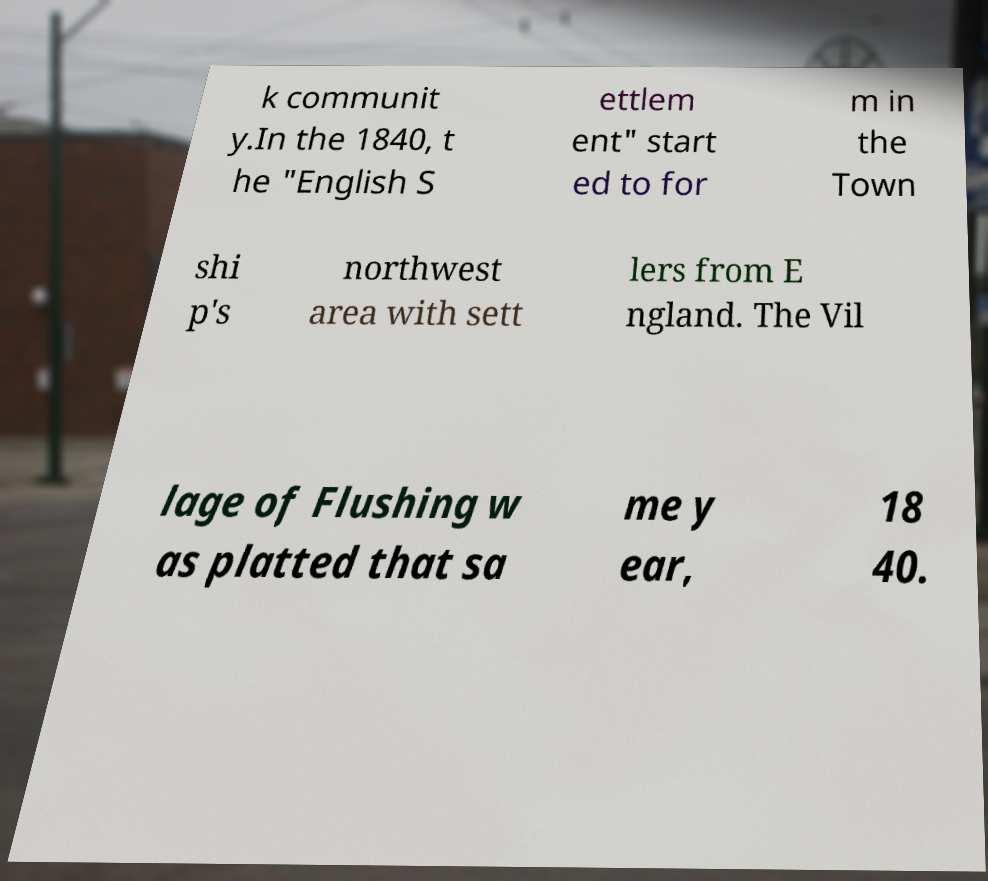Could you extract and type out the text from this image? k communit y.In the 1840, t he "English S ettlem ent" start ed to for m in the Town shi p's northwest area with sett lers from E ngland. The Vil lage of Flushing w as platted that sa me y ear, 18 40. 